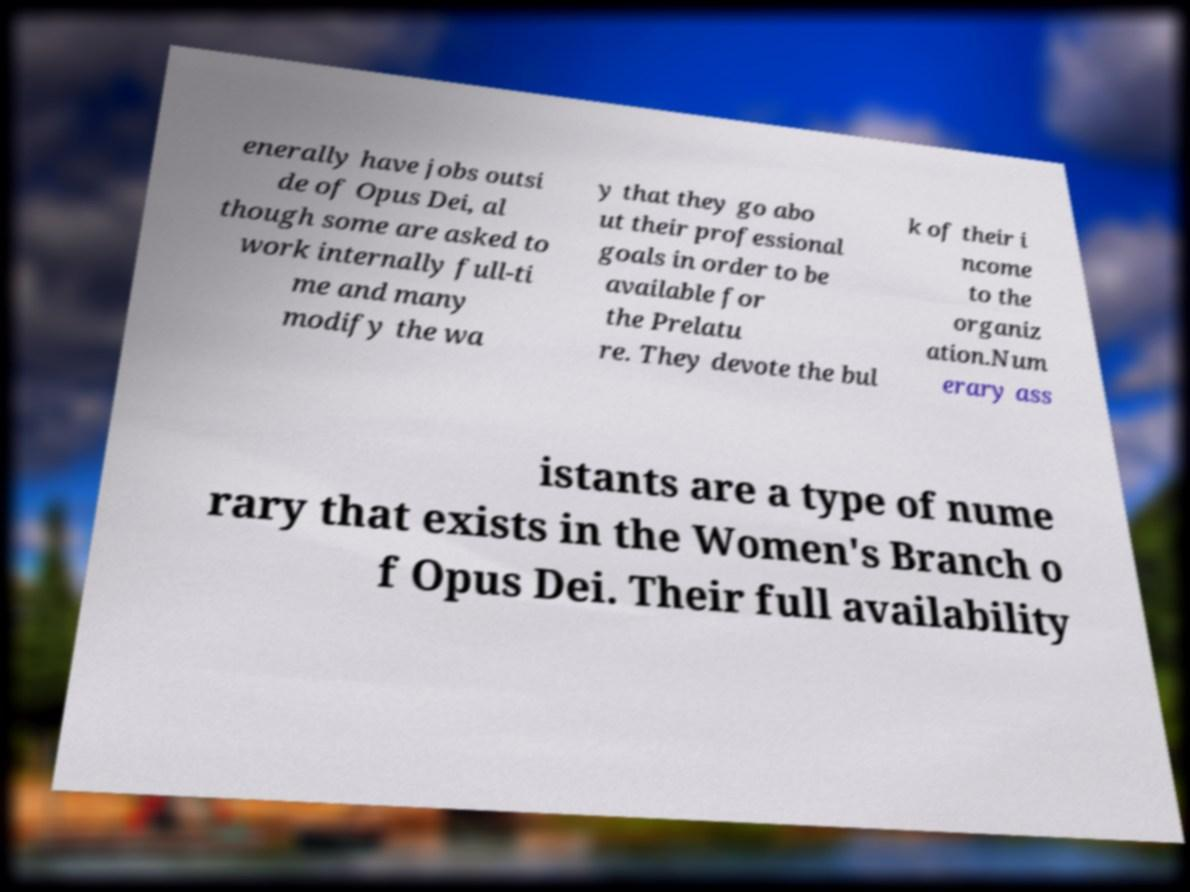Could you extract and type out the text from this image? enerally have jobs outsi de of Opus Dei, al though some are asked to work internally full-ti me and many modify the wa y that they go abo ut their professional goals in order to be available for the Prelatu re. They devote the bul k of their i ncome to the organiz ation.Num erary ass istants are a type of nume rary that exists in the Women's Branch o f Opus Dei. Their full availability 